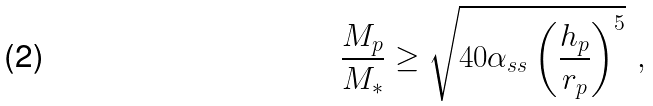Convert formula to latex. <formula><loc_0><loc_0><loc_500><loc_500>\frac { M _ { p } } { M _ { * } } \geq \sqrt { 4 0 \alpha _ { s s } \left ( \frac { h _ { p } } { r _ { p } } \right ) ^ { 5 } } \ ,</formula> 